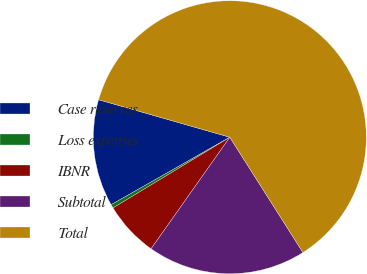<chart> <loc_0><loc_0><loc_500><loc_500><pie_chart><fcel>Case reserves<fcel>Loss expenses<fcel>IBNR<fcel>Subtotal<fcel>Total<nl><fcel>12.66%<fcel>0.44%<fcel>6.55%<fcel>18.78%<fcel>61.57%<nl></chart> 